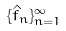Convert formula to latex. <formula><loc_0><loc_0><loc_500><loc_500>\{ \hat { f } _ { n } \} _ { n = 1 } ^ { \infty }</formula> 